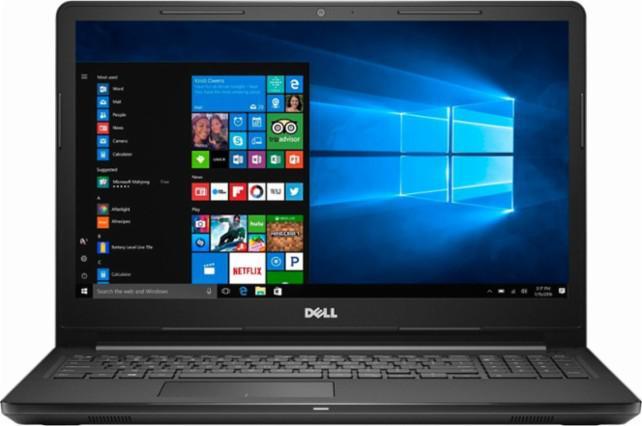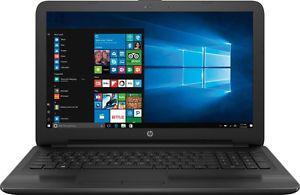The first image is the image on the left, the second image is the image on the right. For the images displayed, is the sentence "All the laptops are fully open with visible screens." factually correct? Answer yes or no. Yes. 